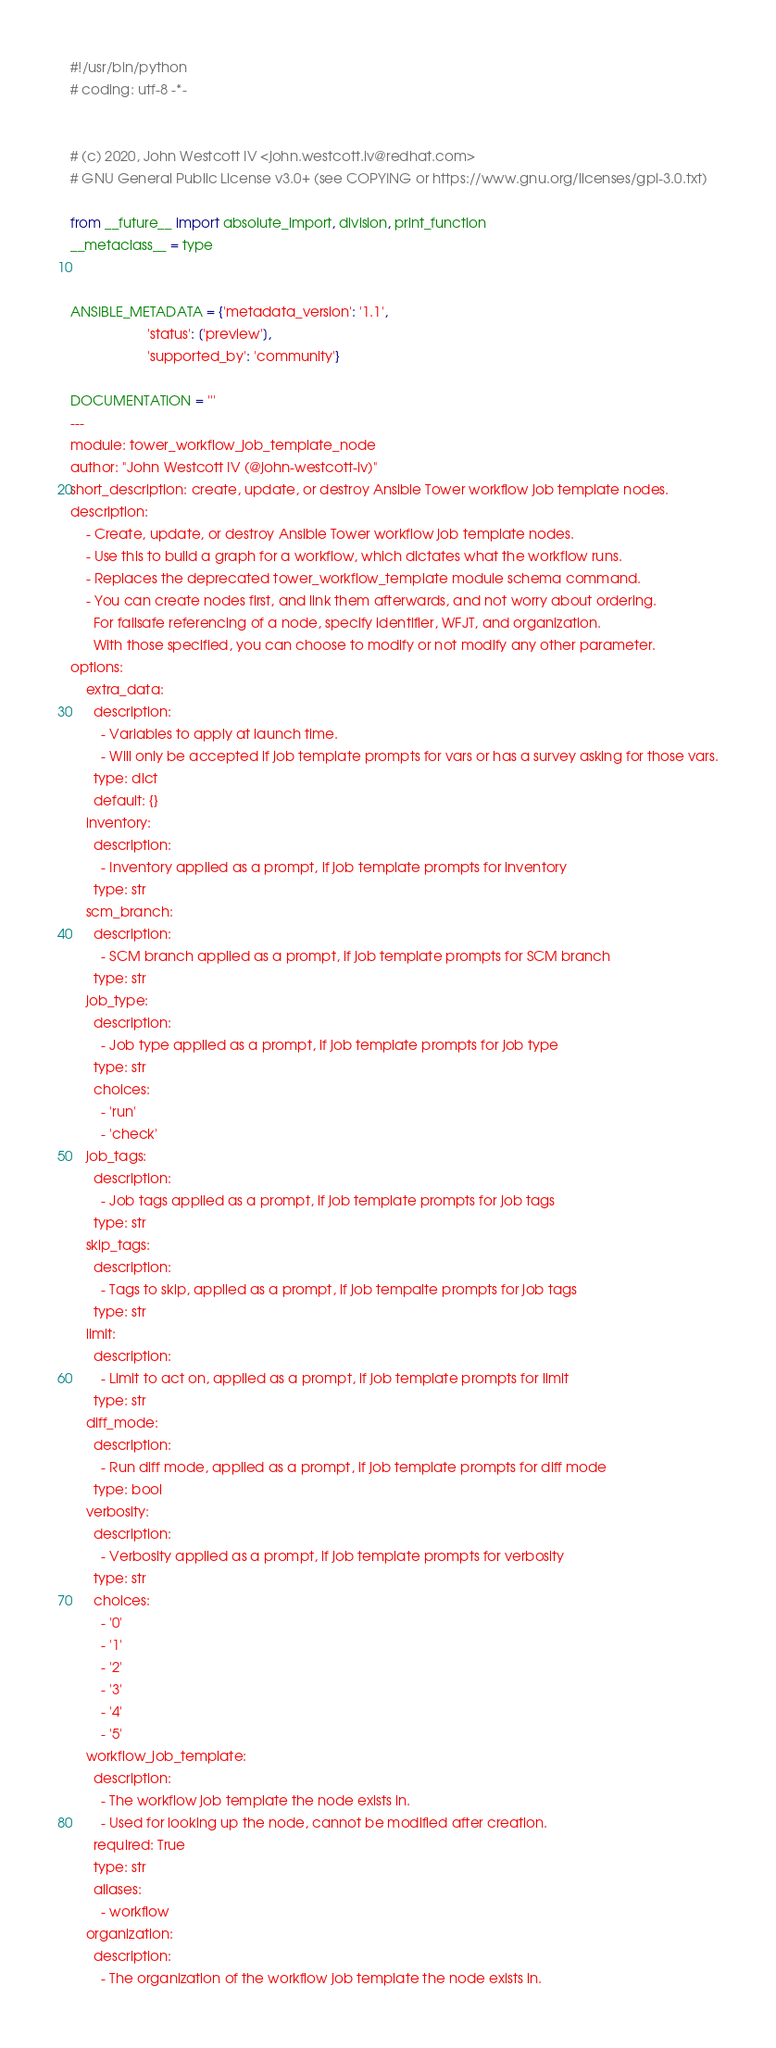Convert code to text. <code><loc_0><loc_0><loc_500><loc_500><_Python_>#!/usr/bin/python
# coding: utf-8 -*-


# (c) 2020, John Westcott IV <john.westcott.iv@redhat.com>
# GNU General Public License v3.0+ (see COPYING or https://www.gnu.org/licenses/gpl-3.0.txt)

from __future__ import absolute_import, division, print_function
__metaclass__ = type


ANSIBLE_METADATA = {'metadata_version': '1.1',
                    'status': ['preview'],
                    'supported_by': 'community'}

DOCUMENTATION = '''
---
module: tower_workflow_job_template_node
author: "John Westcott IV (@john-westcott-iv)"
short_description: create, update, or destroy Ansible Tower workflow job template nodes.
description:
    - Create, update, or destroy Ansible Tower workflow job template nodes.
    - Use this to build a graph for a workflow, which dictates what the workflow runs.
    - Replaces the deprecated tower_workflow_template module schema command.
    - You can create nodes first, and link them afterwards, and not worry about ordering.
      For failsafe referencing of a node, specify identifier, WFJT, and organization.
      With those specified, you can choose to modify or not modify any other parameter.
options:
    extra_data:
      description:
        - Variables to apply at launch time.
        - Will only be accepted if job template prompts for vars or has a survey asking for those vars.
      type: dict
      default: {}
    inventory:
      description:
        - Inventory applied as a prompt, if job template prompts for inventory
      type: str
    scm_branch:
      description:
        - SCM branch applied as a prompt, if job template prompts for SCM branch
      type: str
    job_type:
      description:
        - Job type applied as a prompt, if job template prompts for job type
      type: str
      choices:
        - 'run'
        - 'check'
    job_tags:
      description:
        - Job tags applied as a prompt, if job template prompts for job tags
      type: str
    skip_tags:
      description:
        - Tags to skip, applied as a prompt, if job tempalte prompts for job tags
      type: str
    limit:
      description:
        - Limit to act on, applied as a prompt, if job template prompts for limit
      type: str
    diff_mode:
      description:
        - Run diff mode, applied as a prompt, if job template prompts for diff mode
      type: bool
    verbosity:
      description:
        - Verbosity applied as a prompt, if job template prompts for verbosity
      type: str
      choices:
        - '0'
        - '1'
        - '2'
        - '3'
        - '4'
        - '5'
    workflow_job_template:
      description:
        - The workflow job template the node exists in.
        - Used for looking up the node, cannot be modified after creation.
      required: True
      type: str
      aliases:
        - workflow
    organization:
      description:
        - The organization of the workflow job template the node exists in.</code> 